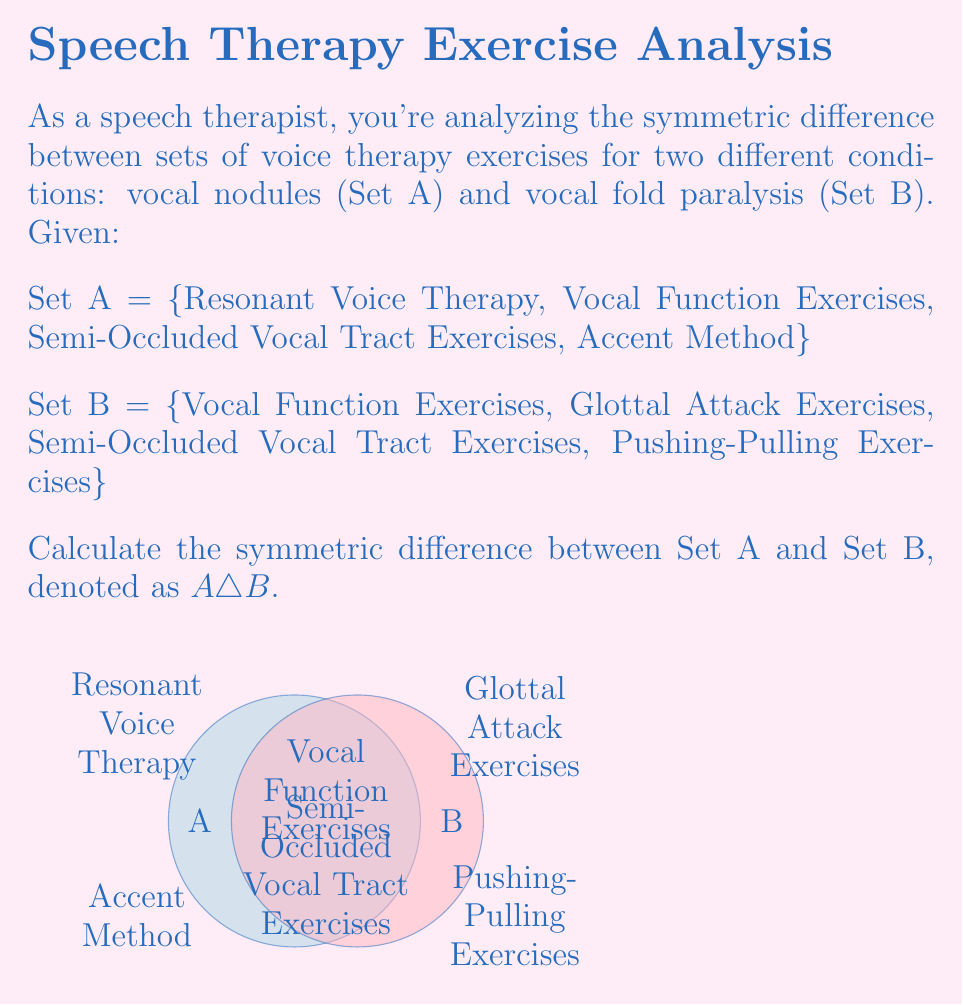Show me your answer to this math problem. To find the symmetric difference between Set A and Set B, we need to follow these steps:

1) Recall that the symmetric difference $A \triangle B$ is defined as the set of elements that are in either A or B, but not in both. Mathematically, this can be expressed as:

   $A \triangle B = (A \setminus B) \cup (B \setminus A)$

2) First, let's find $A \setminus B$ (elements in A but not in B):
   - Resonant Voice Therapy
   - Accent Method

3) Next, let's find $B \setminus A$ (elements in B but not in A):
   - Glottal Attack Exercises
   - Pushing-Pulling Exercises

4) Now, we unite these two sets:
   $A \triangle B = \{$ Resonant Voice Therapy, Accent Method, Glottal Attack Exercises, Pushing-Pulling Exercises $\}$

5) Note that "Vocal Function Exercises" and "Semi-Occluded Vocal Tract Exercises" are present in both sets, so they are not included in the symmetric difference.

Therefore, the symmetric difference $A \triangle B$ consists of the voice therapy exercises that are unique to each condition.
Answer: $A \triangle B = \{$ Resonant Voice Therapy, Accent Method, Glottal Attack Exercises, Pushing-Pulling Exercises $\}$ 